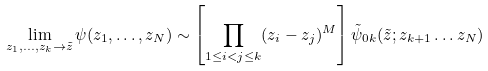Convert formula to latex. <formula><loc_0><loc_0><loc_500><loc_500>\lim _ { z _ { 1 } , \dots , z _ { k } \rightarrow \tilde { z } } \psi ( z _ { 1 } , \dots , z _ { N } ) \sim \left [ \prod _ { 1 \leq i < j \leq k } ( z _ { i } - z _ { j } ) ^ { M } \right ] \tilde { \psi } _ { 0 k } ( \tilde { z } ; z _ { k + 1 } \dots z _ { N } )</formula> 